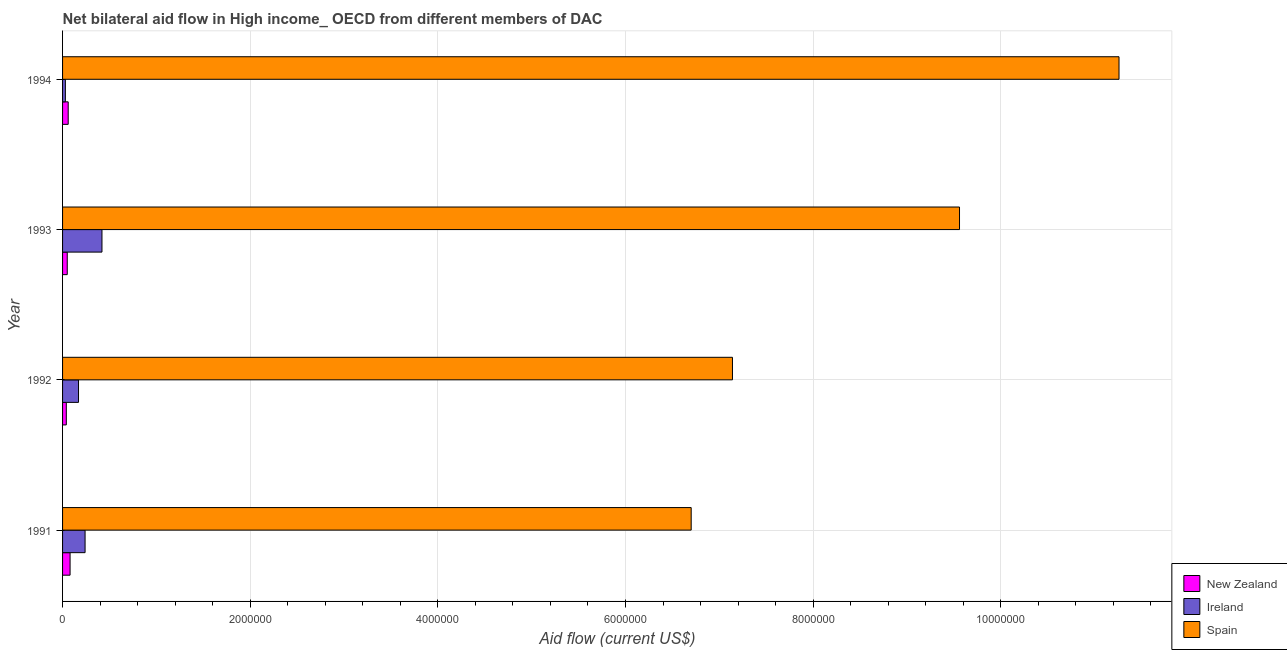How many different coloured bars are there?
Your response must be concise. 3. How many groups of bars are there?
Your answer should be very brief. 4. Are the number of bars on each tick of the Y-axis equal?
Provide a succinct answer. Yes. How many bars are there on the 3rd tick from the top?
Provide a succinct answer. 3. What is the amount of aid provided by spain in 1992?
Your answer should be very brief. 7.14e+06. Across all years, what is the maximum amount of aid provided by ireland?
Make the answer very short. 4.20e+05. Across all years, what is the minimum amount of aid provided by new zealand?
Your response must be concise. 4.00e+04. In which year was the amount of aid provided by spain maximum?
Your response must be concise. 1994. What is the total amount of aid provided by spain in the graph?
Provide a short and direct response. 3.47e+07. What is the difference between the amount of aid provided by ireland in 1992 and that in 1993?
Offer a very short reply. -2.50e+05. What is the difference between the amount of aid provided by new zealand in 1991 and the amount of aid provided by ireland in 1994?
Ensure brevity in your answer.  5.00e+04. What is the average amount of aid provided by new zealand per year?
Give a very brief answer. 5.75e+04. In the year 1993, what is the difference between the amount of aid provided by ireland and amount of aid provided by spain?
Your response must be concise. -9.14e+06. In how many years, is the amount of aid provided by spain greater than 10800000 US$?
Your answer should be very brief. 1. What is the ratio of the amount of aid provided by spain in 1992 to that in 1993?
Make the answer very short. 0.75. Is the amount of aid provided by ireland in 1991 less than that in 1993?
Offer a very short reply. Yes. Is the difference between the amount of aid provided by spain in 1992 and 1994 greater than the difference between the amount of aid provided by ireland in 1992 and 1994?
Ensure brevity in your answer.  No. What is the difference between the highest and the lowest amount of aid provided by spain?
Offer a very short reply. 4.56e+06. Is the sum of the amount of aid provided by new zealand in 1991 and 1993 greater than the maximum amount of aid provided by spain across all years?
Your answer should be compact. No. What does the 2nd bar from the top in 1992 represents?
Make the answer very short. Ireland. What does the 2nd bar from the bottom in 1992 represents?
Give a very brief answer. Ireland. Are all the bars in the graph horizontal?
Ensure brevity in your answer.  Yes. How many years are there in the graph?
Your response must be concise. 4. What is the difference between two consecutive major ticks on the X-axis?
Ensure brevity in your answer.  2.00e+06. Does the graph contain any zero values?
Your response must be concise. No. Does the graph contain grids?
Provide a succinct answer. Yes. Where does the legend appear in the graph?
Offer a very short reply. Bottom right. What is the title of the graph?
Your response must be concise. Net bilateral aid flow in High income_ OECD from different members of DAC. What is the label or title of the Y-axis?
Your response must be concise. Year. What is the Aid flow (current US$) of New Zealand in 1991?
Your answer should be very brief. 8.00e+04. What is the Aid flow (current US$) in Spain in 1991?
Offer a very short reply. 6.70e+06. What is the Aid flow (current US$) of Ireland in 1992?
Provide a succinct answer. 1.70e+05. What is the Aid flow (current US$) in Spain in 1992?
Provide a succinct answer. 7.14e+06. What is the Aid flow (current US$) in Spain in 1993?
Your answer should be very brief. 9.56e+06. What is the Aid flow (current US$) of New Zealand in 1994?
Your response must be concise. 6.00e+04. What is the Aid flow (current US$) in Spain in 1994?
Provide a short and direct response. 1.13e+07. Across all years, what is the maximum Aid flow (current US$) of Spain?
Ensure brevity in your answer.  1.13e+07. Across all years, what is the minimum Aid flow (current US$) of New Zealand?
Ensure brevity in your answer.  4.00e+04. Across all years, what is the minimum Aid flow (current US$) in Spain?
Give a very brief answer. 6.70e+06. What is the total Aid flow (current US$) of Ireland in the graph?
Your answer should be compact. 8.60e+05. What is the total Aid flow (current US$) in Spain in the graph?
Ensure brevity in your answer.  3.47e+07. What is the difference between the Aid flow (current US$) in Ireland in 1991 and that in 1992?
Provide a short and direct response. 7.00e+04. What is the difference between the Aid flow (current US$) of Spain in 1991 and that in 1992?
Provide a short and direct response. -4.40e+05. What is the difference between the Aid flow (current US$) of Spain in 1991 and that in 1993?
Your response must be concise. -2.86e+06. What is the difference between the Aid flow (current US$) in Ireland in 1991 and that in 1994?
Ensure brevity in your answer.  2.10e+05. What is the difference between the Aid flow (current US$) in Spain in 1991 and that in 1994?
Keep it short and to the point. -4.56e+06. What is the difference between the Aid flow (current US$) in New Zealand in 1992 and that in 1993?
Your answer should be very brief. -10000. What is the difference between the Aid flow (current US$) of Ireland in 1992 and that in 1993?
Offer a terse response. -2.50e+05. What is the difference between the Aid flow (current US$) in Spain in 1992 and that in 1993?
Keep it short and to the point. -2.42e+06. What is the difference between the Aid flow (current US$) in New Zealand in 1992 and that in 1994?
Keep it short and to the point. -2.00e+04. What is the difference between the Aid flow (current US$) of Ireland in 1992 and that in 1994?
Your answer should be compact. 1.40e+05. What is the difference between the Aid flow (current US$) in Spain in 1992 and that in 1994?
Give a very brief answer. -4.12e+06. What is the difference between the Aid flow (current US$) of Ireland in 1993 and that in 1994?
Your answer should be very brief. 3.90e+05. What is the difference between the Aid flow (current US$) in Spain in 1993 and that in 1994?
Give a very brief answer. -1.70e+06. What is the difference between the Aid flow (current US$) in New Zealand in 1991 and the Aid flow (current US$) in Spain in 1992?
Provide a succinct answer. -7.06e+06. What is the difference between the Aid flow (current US$) in Ireland in 1991 and the Aid flow (current US$) in Spain in 1992?
Keep it short and to the point. -6.90e+06. What is the difference between the Aid flow (current US$) in New Zealand in 1991 and the Aid flow (current US$) in Ireland in 1993?
Give a very brief answer. -3.40e+05. What is the difference between the Aid flow (current US$) in New Zealand in 1991 and the Aid flow (current US$) in Spain in 1993?
Your answer should be compact. -9.48e+06. What is the difference between the Aid flow (current US$) of Ireland in 1991 and the Aid flow (current US$) of Spain in 1993?
Make the answer very short. -9.32e+06. What is the difference between the Aid flow (current US$) of New Zealand in 1991 and the Aid flow (current US$) of Ireland in 1994?
Give a very brief answer. 5.00e+04. What is the difference between the Aid flow (current US$) in New Zealand in 1991 and the Aid flow (current US$) in Spain in 1994?
Make the answer very short. -1.12e+07. What is the difference between the Aid flow (current US$) of Ireland in 1991 and the Aid flow (current US$) of Spain in 1994?
Provide a short and direct response. -1.10e+07. What is the difference between the Aid flow (current US$) of New Zealand in 1992 and the Aid flow (current US$) of Ireland in 1993?
Offer a very short reply. -3.80e+05. What is the difference between the Aid flow (current US$) in New Zealand in 1992 and the Aid flow (current US$) in Spain in 1993?
Offer a terse response. -9.52e+06. What is the difference between the Aid flow (current US$) in Ireland in 1992 and the Aid flow (current US$) in Spain in 1993?
Your answer should be compact. -9.39e+06. What is the difference between the Aid flow (current US$) in New Zealand in 1992 and the Aid flow (current US$) in Ireland in 1994?
Offer a very short reply. 10000. What is the difference between the Aid flow (current US$) of New Zealand in 1992 and the Aid flow (current US$) of Spain in 1994?
Make the answer very short. -1.12e+07. What is the difference between the Aid flow (current US$) of Ireland in 1992 and the Aid flow (current US$) of Spain in 1994?
Your answer should be compact. -1.11e+07. What is the difference between the Aid flow (current US$) of New Zealand in 1993 and the Aid flow (current US$) of Spain in 1994?
Keep it short and to the point. -1.12e+07. What is the difference between the Aid flow (current US$) in Ireland in 1993 and the Aid flow (current US$) in Spain in 1994?
Give a very brief answer. -1.08e+07. What is the average Aid flow (current US$) in New Zealand per year?
Ensure brevity in your answer.  5.75e+04. What is the average Aid flow (current US$) of Ireland per year?
Provide a succinct answer. 2.15e+05. What is the average Aid flow (current US$) in Spain per year?
Give a very brief answer. 8.66e+06. In the year 1991, what is the difference between the Aid flow (current US$) of New Zealand and Aid flow (current US$) of Spain?
Your answer should be very brief. -6.62e+06. In the year 1991, what is the difference between the Aid flow (current US$) in Ireland and Aid flow (current US$) in Spain?
Provide a short and direct response. -6.46e+06. In the year 1992, what is the difference between the Aid flow (current US$) of New Zealand and Aid flow (current US$) of Spain?
Your answer should be very brief. -7.10e+06. In the year 1992, what is the difference between the Aid flow (current US$) in Ireland and Aid flow (current US$) in Spain?
Your answer should be compact. -6.97e+06. In the year 1993, what is the difference between the Aid flow (current US$) of New Zealand and Aid flow (current US$) of Ireland?
Make the answer very short. -3.70e+05. In the year 1993, what is the difference between the Aid flow (current US$) of New Zealand and Aid flow (current US$) of Spain?
Provide a short and direct response. -9.51e+06. In the year 1993, what is the difference between the Aid flow (current US$) in Ireland and Aid flow (current US$) in Spain?
Offer a very short reply. -9.14e+06. In the year 1994, what is the difference between the Aid flow (current US$) of New Zealand and Aid flow (current US$) of Ireland?
Offer a very short reply. 3.00e+04. In the year 1994, what is the difference between the Aid flow (current US$) in New Zealand and Aid flow (current US$) in Spain?
Your response must be concise. -1.12e+07. In the year 1994, what is the difference between the Aid flow (current US$) in Ireland and Aid flow (current US$) in Spain?
Give a very brief answer. -1.12e+07. What is the ratio of the Aid flow (current US$) in Ireland in 1991 to that in 1992?
Your response must be concise. 1.41. What is the ratio of the Aid flow (current US$) in Spain in 1991 to that in 1992?
Keep it short and to the point. 0.94. What is the ratio of the Aid flow (current US$) of New Zealand in 1991 to that in 1993?
Provide a short and direct response. 1.6. What is the ratio of the Aid flow (current US$) in Ireland in 1991 to that in 1993?
Provide a short and direct response. 0.57. What is the ratio of the Aid flow (current US$) of Spain in 1991 to that in 1993?
Offer a very short reply. 0.7. What is the ratio of the Aid flow (current US$) of New Zealand in 1991 to that in 1994?
Your answer should be compact. 1.33. What is the ratio of the Aid flow (current US$) in Ireland in 1991 to that in 1994?
Make the answer very short. 8. What is the ratio of the Aid flow (current US$) in Spain in 1991 to that in 1994?
Your answer should be compact. 0.59. What is the ratio of the Aid flow (current US$) of Ireland in 1992 to that in 1993?
Your answer should be very brief. 0.4. What is the ratio of the Aid flow (current US$) of Spain in 1992 to that in 1993?
Ensure brevity in your answer.  0.75. What is the ratio of the Aid flow (current US$) of New Zealand in 1992 to that in 1994?
Keep it short and to the point. 0.67. What is the ratio of the Aid flow (current US$) in Ireland in 1992 to that in 1994?
Your answer should be very brief. 5.67. What is the ratio of the Aid flow (current US$) of Spain in 1992 to that in 1994?
Your response must be concise. 0.63. What is the ratio of the Aid flow (current US$) in Spain in 1993 to that in 1994?
Keep it short and to the point. 0.85. What is the difference between the highest and the second highest Aid flow (current US$) in Spain?
Provide a short and direct response. 1.70e+06. What is the difference between the highest and the lowest Aid flow (current US$) in New Zealand?
Offer a very short reply. 4.00e+04. What is the difference between the highest and the lowest Aid flow (current US$) of Ireland?
Your answer should be very brief. 3.90e+05. What is the difference between the highest and the lowest Aid flow (current US$) in Spain?
Make the answer very short. 4.56e+06. 